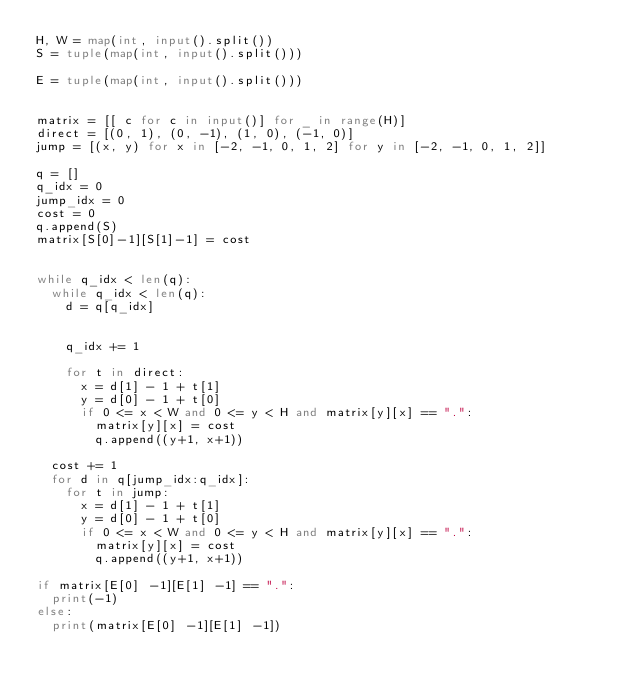<code> <loc_0><loc_0><loc_500><loc_500><_Python_>H, W = map(int, input().split())
S = tuple(map(int, input().split()))

E = tuple(map(int, input().split()))


matrix = [[ c for c in input()] for _ in range(H)]
direct = [(0, 1), (0, -1), (1, 0), (-1, 0)]
jump = [(x, y) for x in [-2, -1, 0, 1, 2] for y in [-2, -1, 0, 1, 2]]

q = []
q_idx = 0
jump_idx = 0
cost = 0
q.append(S)
matrix[S[0]-1][S[1]-1] = cost


while q_idx < len(q):
  while q_idx < len(q):
    d = q[q_idx]

    
    q_idx += 1

    for t in direct:
      x = d[1] - 1 + t[1]
      y = d[0] - 1 + t[0]
      if 0 <= x < W and 0 <= y < H and matrix[y][x] == ".":
        matrix[y][x] = cost
        q.append((y+1, x+1))
  
  cost += 1
  for d in q[jump_idx:q_idx]:
    for t in jump:
      x = d[1] - 1 + t[1]
      y = d[0] - 1 + t[0]
      if 0 <= x < W and 0 <= y < H and matrix[y][x] == ".":
        matrix[y][x] = cost
        q.append((y+1, x+1))

if matrix[E[0] -1][E[1] -1] == ".":
  print(-1)
else:
  print(matrix[E[0] -1][E[1] -1])
</code> 